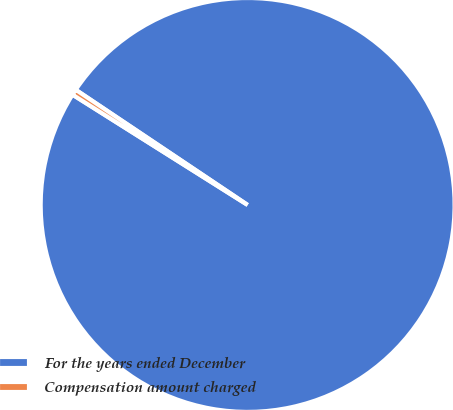Convert chart. <chart><loc_0><loc_0><loc_500><loc_500><pie_chart><fcel>For the years ended December<fcel>Compensation amount charged<nl><fcel>99.55%<fcel>0.45%<nl></chart> 